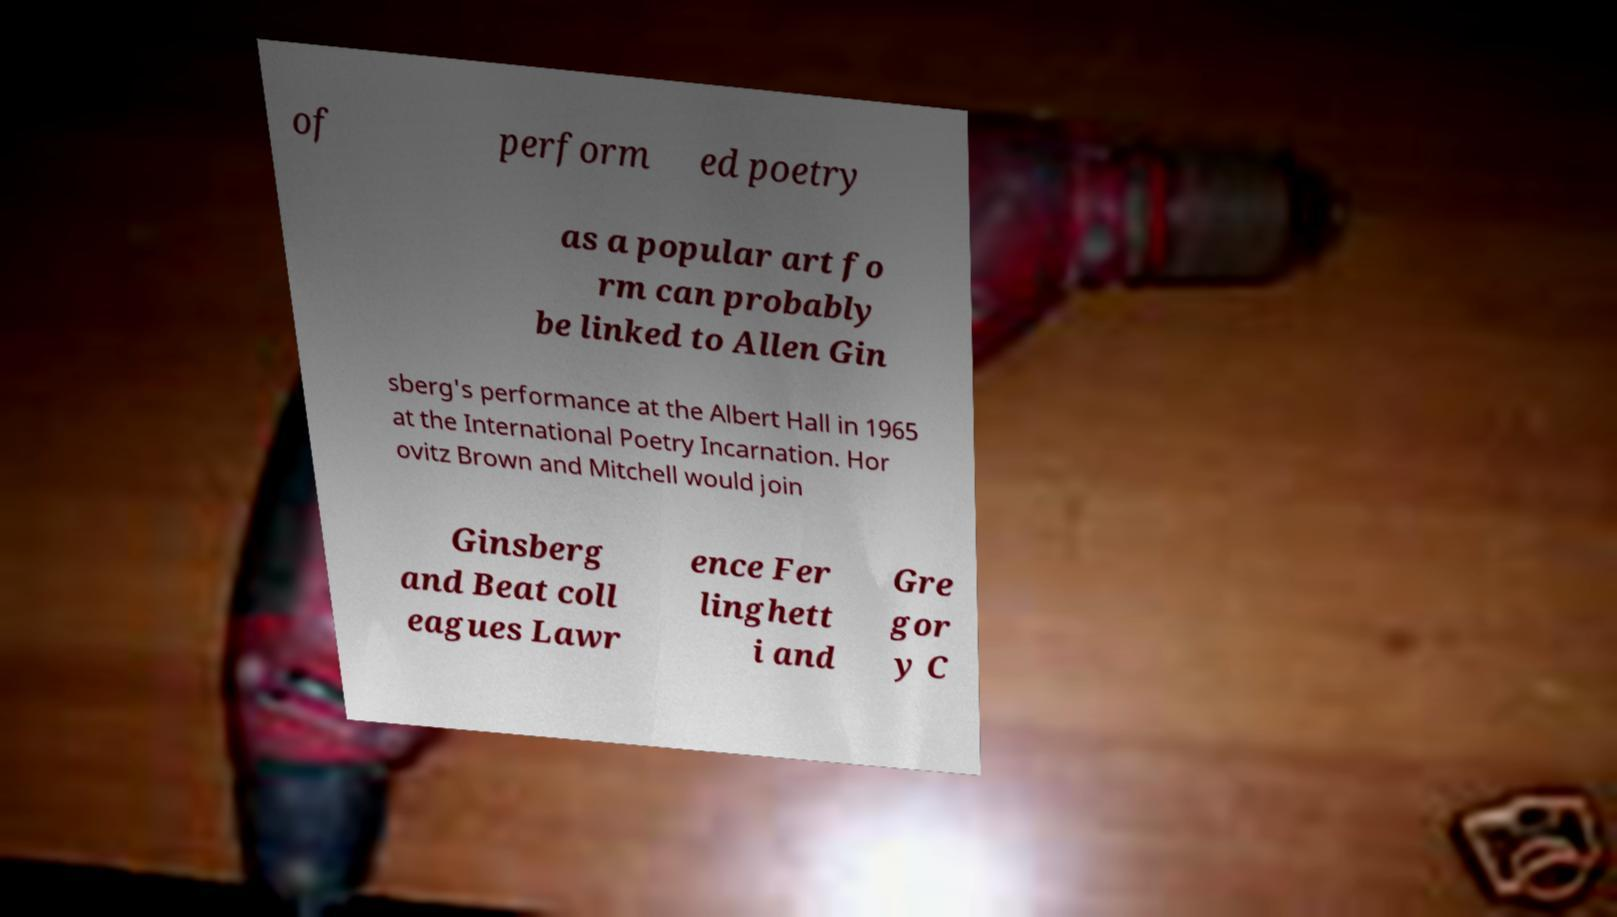Could you extract and type out the text from this image? of perform ed poetry as a popular art fo rm can probably be linked to Allen Gin sberg's performance at the Albert Hall in 1965 at the International Poetry Incarnation. Hor ovitz Brown and Mitchell would join Ginsberg and Beat coll eagues Lawr ence Fer linghett i and Gre gor y C 